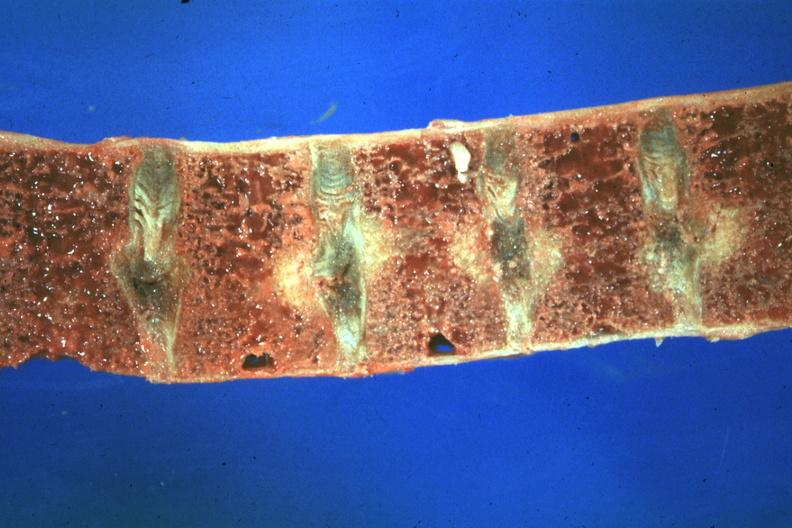how does this image show close-up view very good case of 48yowm?
Answer the question using a single word or phrase. With hypertension renal failure and secondary parathyroid hyperplasia 